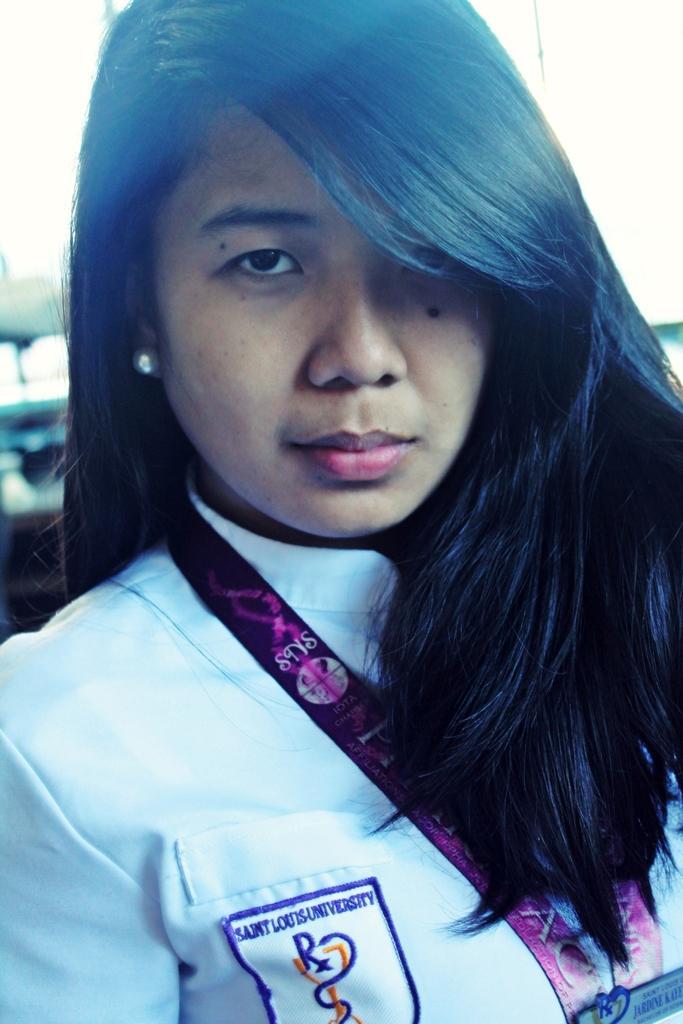Could you give a brief overview of what you see in this image? In this image we can see a lady wearing white color dress, and an access card, and she has a sticker with some written on it, and the background is blurred. 